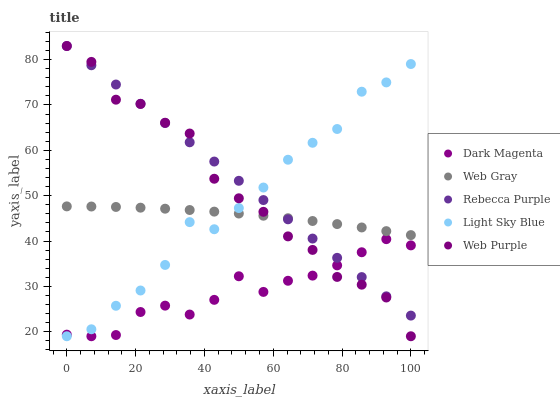Does Dark Magenta have the minimum area under the curve?
Answer yes or no. Yes. Does Rebecca Purple have the maximum area under the curve?
Answer yes or no. Yes. Does Web Gray have the minimum area under the curve?
Answer yes or no. No. Does Web Gray have the maximum area under the curve?
Answer yes or no. No. Is Rebecca Purple the smoothest?
Answer yes or no. Yes. Is Web Purple the roughest?
Answer yes or no. Yes. Is Web Gray the smoothest?
Answer yes or no. No. Is Web Gray the roughest?
Answer yes or no. No. Does Web Purple have the lowest value?
Answer yes or no. Yes. Does Web Gray have the lowest value?
Answer yes or no. No. Does Rebecca Purple have the highest value?
Answer yes or no. Yes. Does Web Gray have the highest value?
Answer yes or no. No. Is Dark Magenta less than Web Gray?
Answer yes or no. Yes. Is Web Gray greater than Dark Magenta?
Answer yes or no. Yes. Does Web Purple intersect Web Gray?
Answer yes or no. Yes. Is Web Purple less than Web Gray?
Answer yes or no. No. Is Web Purple greater than Web Gray?
Answer yes or no. No. Does Dark Magenta intersect Web Gray?
Answer yes or no. No. 